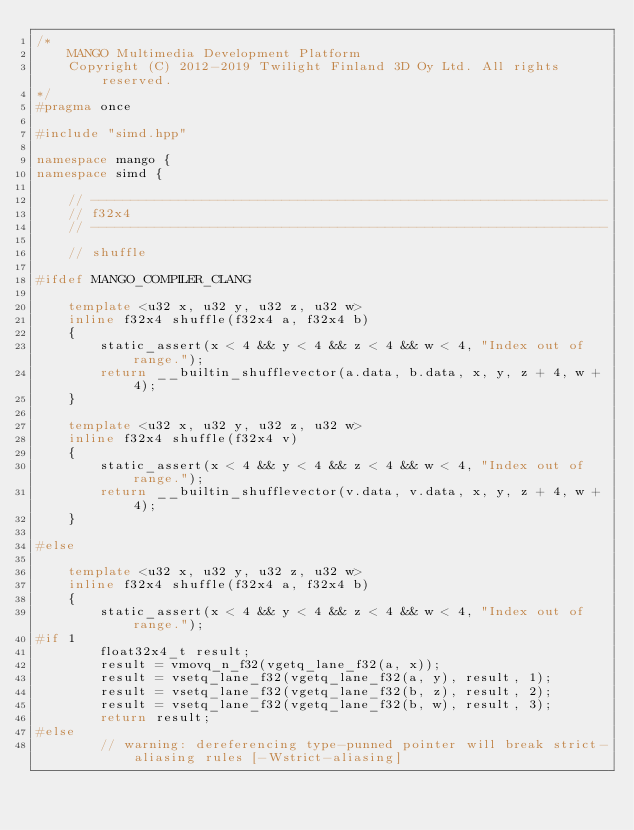Convert code to text. <code><loc_0><loc_0><loc_500><loc_500><_C++_>/*
    MANGO Multimedia Development Platform
    Copyright (C) 2012-2019 Twilight Finland 3D Oy Ltd. All rights reserved.
*/
#pragma once

#include "simd.hpp"

namespace mango {
namespace simd {

    // -----------------------------------------------------------------
    // f32x4
    // -----------------------------------------------------------------

    // shuffle

#ifdef MANGO_COMPILER_CLANG

    template <u32 x, u32 y, u32 z, u32 w>
    inline f32x4 shuffle(f32x4 a, f32x4 b)
    {
        static_assert(x < 4 && y < 4 && z < 4 && w < 4, "Index out of range.");
        return __builtin_shufflevector(a.data, b.data, x, y, z + 4, w + 4);
    }

    template <u32 x, u32 y, u32 z, u32 w>
    inline f32x4 shuffle(f32x4 v)
    {
        static_assert(x < 4 && y < 4 && z < 4 && w < 4, "Index out of range.");
        return __builtin_shufflevector(v.data, v.data, x, y, z + 4, w + 4);
    }

#else

    template <u32 x, u32 y, u32 z, u32 w>
    inline f32x4 shuffle(f32x4 a, f32x4 b)
    {
        static_assert(x < 4 && y < 4 && z < 4 && w < 4, "Index out of range.");
#if 1
        float32x4_t result;
	    result = vmovq_n_f32(vgetq_lane_f32(a, x));
	    result = vsetq_lane_f32(vgetq_lane_f32(a, y), result, 1);
	    result = vsetq_lane_f32(vgetq_lane_f32(b, z), result, 2);
	    result = vsetq_lane_f32(vgetq_lane_f32(b, w), result, 3);
        return result;
#else
        // warning: dereferencing type-punned pointer will break strict-aliasing rules [-Wstrict-aliasing]</code> 